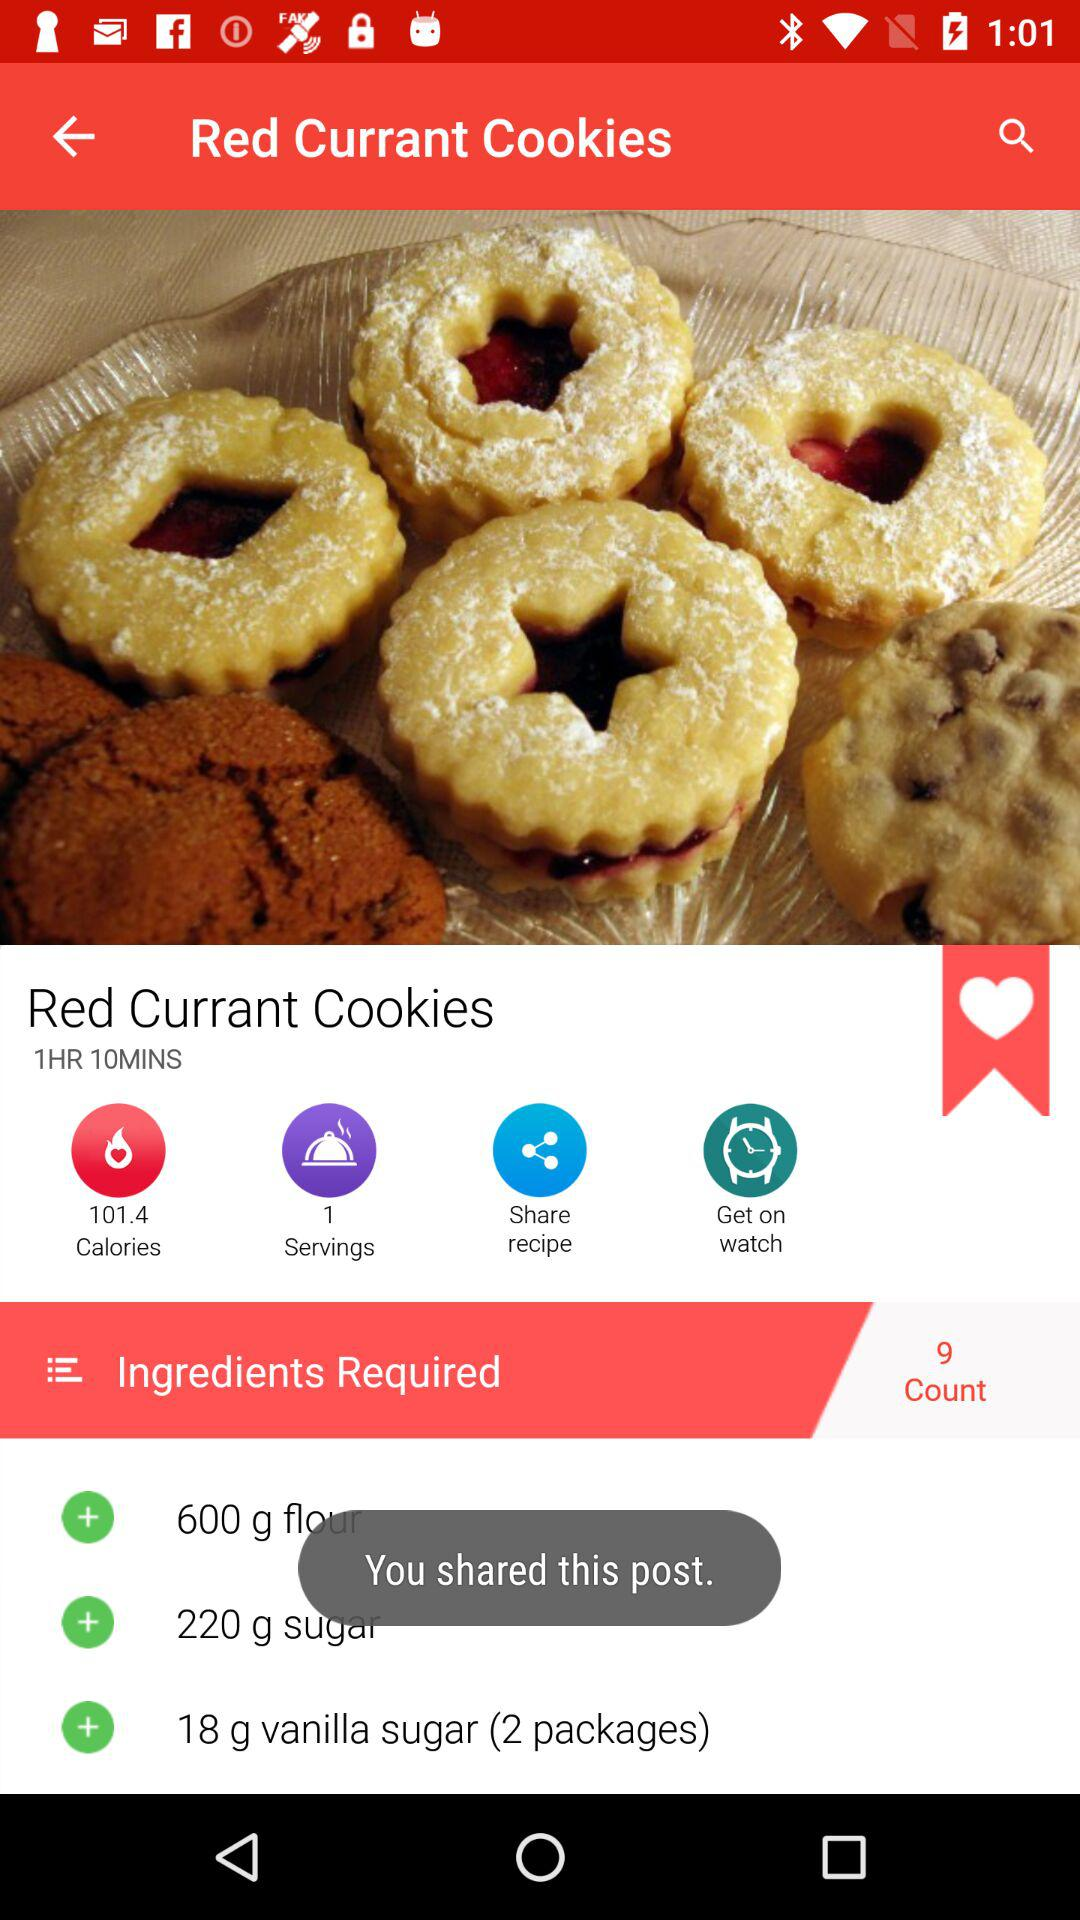How many ounces of currants are required for the recipe?
When the provided information is insufficient, respond with <no answer>. <no answer> 